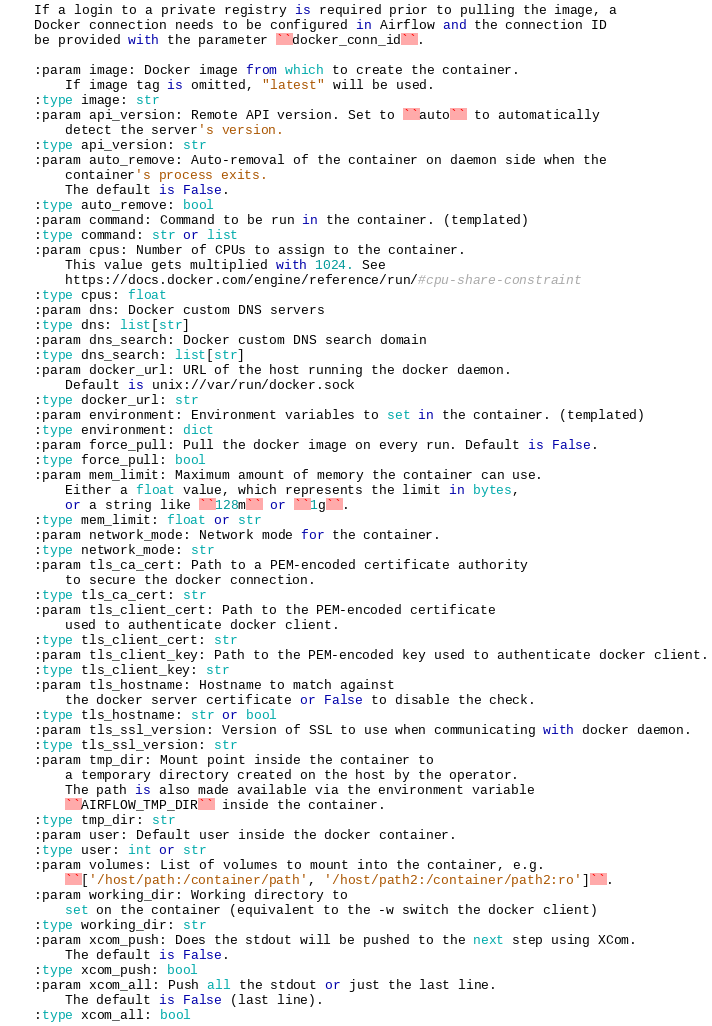<code> <loc_0><loc_0><loc_500><loc_500><_Python_>
    If a login to a private registry is required prior to pulling the image, a
    Docker connection needs to be configured in Airflow and the connection ID
    be provided with the parameter ``docker_conn_id``.

    :param image: Docker image from which to create the container.
        If image tag is omitted, "latest" will be used.
    :type image: str
    :param api_version: Remote API version. Set to ``auto`` to automatically
        detect the server's version.
    :type api_version: str
    :param auto_remove: Auto-removal of the container on daemon side when the
        container's process exits.
        The default is False.
    :type auto_remove: bool
    :param command: Command to be run in the container. (templated)
    :type command: str or list
    :param cpus: Number of CPUs to assign to the container.
        This value gets multiplied with 1024. See
        https://docs.docker.com/engine/reference/run/#cpu-share-constraint
    :type cpus: float
    :param dns: Docker custom DNS servers
    :type dns: list[str]
    :param dns_search: Docker custom DNS search domain
    :type dns_search: list[str]
    :param docker_url: URL of the host running the docker daemon.
        Default is unix://var/run/docker.sock
    :type docker_url: str
    :param environment: Environment variables to set in the container. (templated)
    :type environment: dict
    :param force_pull: Pull the docker image on every run. Default is False.
    :type force_pull: bool
    :param mem_limit: Maximum amount of memory the container can use.
        Either a float value, which represents the limit in bytes,
        or a string like ``128m`` or ``1g``.
    :type mem_limit: float or str
    :param network_mode: Network mode for the container.
    :type network_mode: str
    :param tls_ca_cert: Path to a PEM-encoded certificate authority
        to secure the docker connection.
    :type tls_ca_cert: str
    :param tls_client_cert: Path to the PEM-encoded certificate
        used to authenticate docker client.
    :type tls_client_cert: str
    :param tls_client_key: Path to the PEM-encoded key used to authenticate docker client.
    :type tls_client_key: str
    :param tls_hostname: Hostname to match against
        the docker server certificate or False to disable the check.
    :type tls_hostname: str or bool
    :param tls_ssl_version: Version of SSL to use when communicating with docker daemon.
    :type tls_ssl_version: str
    :param tmp_dir: Mount point inside the container to
        a temporary directory created on the host by the operator.
        The path is also made available via the environment variable
        ``AIRFLOW_TMP_DIR`` inside the container.
    :type tmp_dir: str
    :param user: Default user inside the docker container.
    :type user: int or str
    :param volumes: List of volumes to mount into the container, e.g.
        ``['/host/path:/container/path', '/host/path2:/container/path2:ro']``.
    :param working_dir: Working directory to
        set on the container (equivalent to the -w switch the docker client)
    :type working_dir: str
    :param xcom_push: Does the stdout will be pushed to the next step using XCom.
        The default is False.
    :type xcom_push: bool
    :param xcom_all: Push all the stdout or just the last line.
        The default is False (last line).
    :type xcom_all: bool</code> 